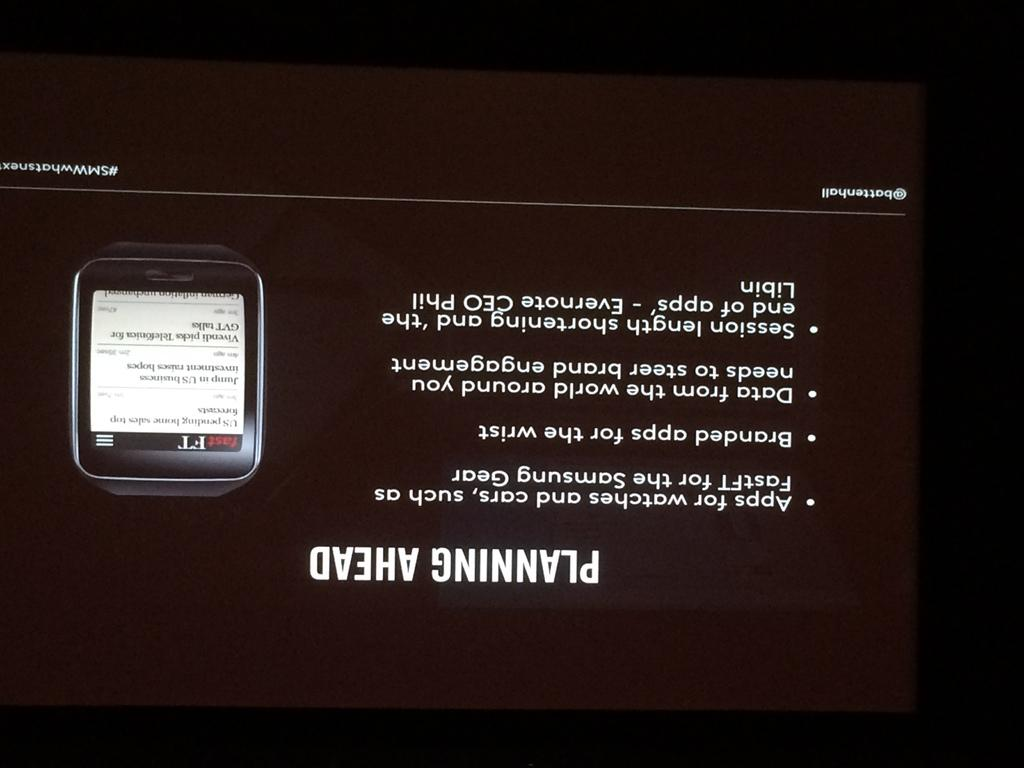<image>
Relay a brief, clear account of the picture shown. A power point slide picture of a smart watch contains tips for planning ahead. 